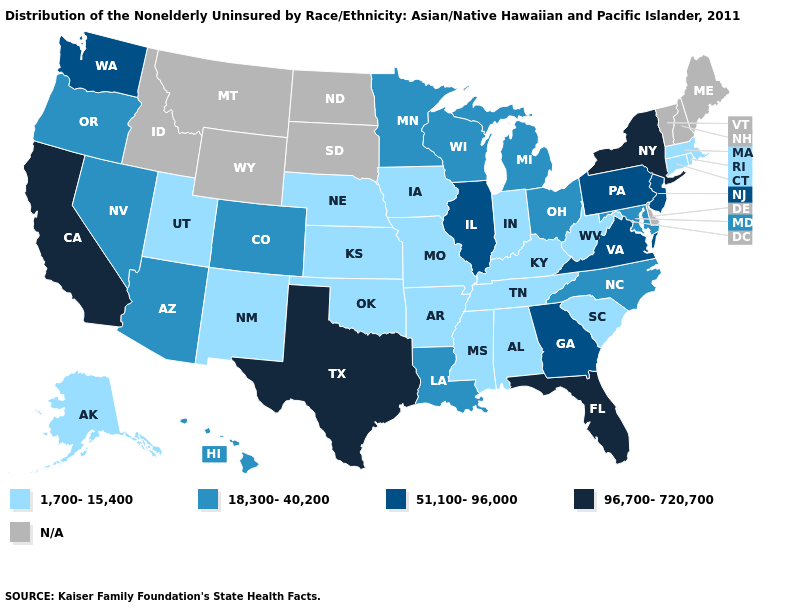Among the states that border Wyoming , which have the highest value?
Write a very short answer. Colorado. What is the lowest value in states that border Iowa?
Keep it brief. 1,700-15,400. What is the value of South Dakota?
Answer briefly. N/A. What is the lowest value in the West?
Concise answer only. 1,700-15,400. What is the value of Alaska?
Concise answer only. 1,700-15,400. What is the highest value in the MidWest ?
Give a very brief answer. 51,100-96,000. Name the states that have a value in the range N/A?
Give a very brief answer. Delaware, Idaho, Maine, Montana, New Hampshire, North Dakota, South Dakota, Vermont, Wyoming. What is the value of Hawaii?
Concise answer only. 18,300-40,200. Does Indiana have the lowest value in the MidWest?
Write a very short answer. Yes. What is the highest value in the South ?
Concise answer only. 96,700-720,700. Among the states that border Pennsylvania , does New York have the highest value?
Keep it brief. Yes. Is the legend a continuous bar?
Be succinct. No. What is the highest value in the USA?
Quick response, please. 96,700-720,700. Name the states that have a value in the range 18,300-40,200?
Short answer required. Arizona, Colorado, Hawaii, Louisiana, Maryland, Michigan, Minnesota, Nevada, North Carolina, Ohio, Oregon, Wisconsin. 